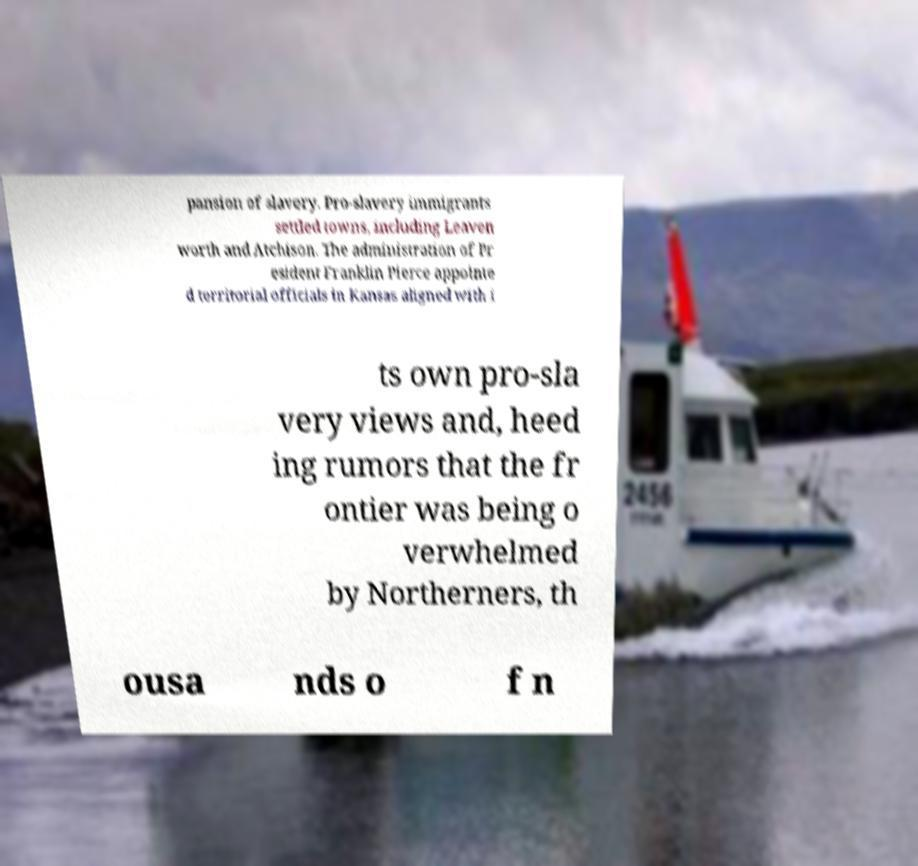I need the written content from this picture converted into text. Can you do that? pansion of slavery. Pro-slavery immigrants settled towns, including Leaven worth and Atchison. The administration of Pr esident Franklin Pierce appointe d territorial officials in Kansas aligned with i ts own pro-sla very views and, heed ing rumors that the fr ontier was being o verwhelmed by Northerners, th ousa nds o f n 